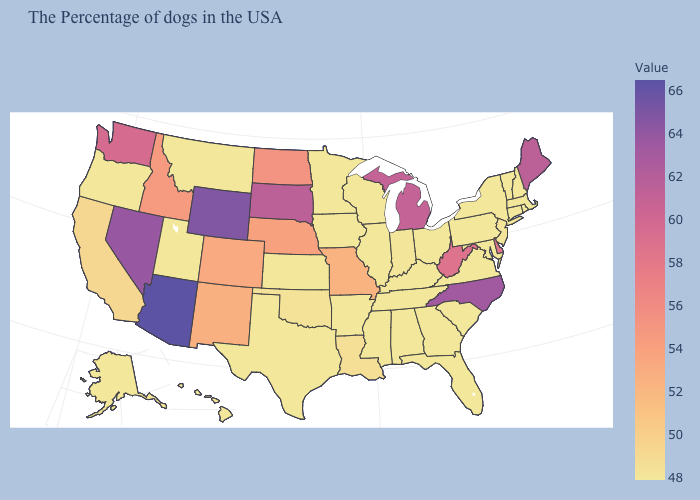Which states have the lowest value in the South?
Write a very short answer. Maryland, Virginia, South Carolina, Florida, Georgia, Kentucky, Alabama, Tennessee, Mississippi, Arkansas, Texas. Among the states that border Idaho , does Oregon have the lowest value?
Concise answer only. Yes. Which states hav the highest value in the South?
Quick response, please. North Carolina. 